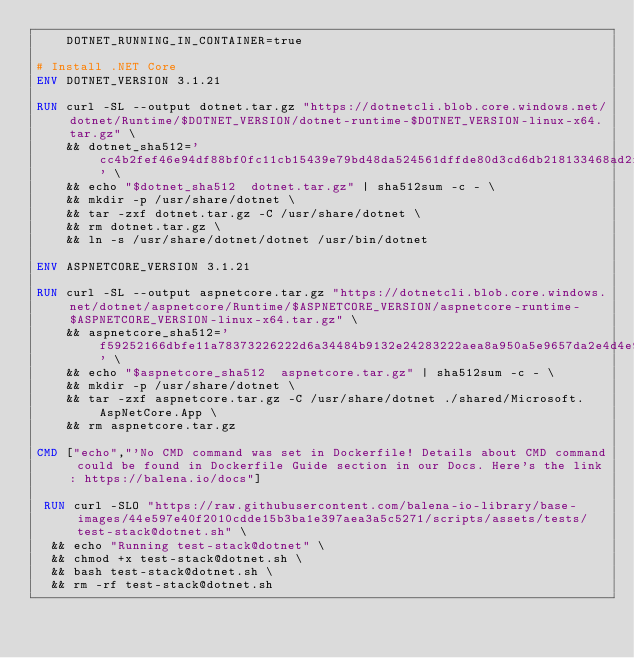<code> <loc_0><loc_0><loc_500><loc_500><_Dockerfile_>    DOTNET_RUNNING_IN_CONTAINER=true

# Install .NET Core
ENV DOTNET_VERSION 3.1.21

RUN curl -SL --output dotnet.tar.gz "https://dotnetcli.blob.core.windows.net/dotnet/Runtime/$DOTNET_VERSION/dotnet-runtime-$DOTNET_VERSION-linux-x64.tar.gz" \
    && dotnet_sha512='cc4b2fef46e94df88bf0fc11cb15439e79bd48da524561dffde80d3cd6db218133468ad2f6785803cf0c13f000d95ff71eb258cec76dd8eb809676ec1cb38fac' \
    && echo "$dotnet_sha512  dotnet.tar.gz" | sha512sum -c - \
    && mkdir -p /usr/share/dotnet \
    && tar -zxf dotnet.tar.gz -C /usr/share/dotnet \
    && rm dotnet.tar.gz \
    && ln -s /usr/share/dotnet/dotnet /usr/bin/dotnet

ENV ASPNETCORE_VERSION 3.1.21

RUN curl -SL --output aspnetcore.tar.gz "https://dotnetcli.blob.core.windows.net/dotnet/aspnetcore/Runtime/$ASPNETCORE_VERSION/aspnetcore-runtime-$ASPNETCORE_VERSION-linux-x64.tar.gz" \
    && aspnetcore_sha512='f59252166dbfe11a78373226222d6a34484b9132e24283222aea8a950a5e9657da2e4d4e9ff8cbcc2fd7c7705e13bf42a31232a6012d1e247efc718e3d8e2df1' \
    && echo "$aspnetcore_sha512  aspnetcore.tar.gz" | sha512sum -c - \
    && mkdir -p /usr/share/dotnet \
    && tar -zxf aspnetcore.tar.gz -C /usr/share/dotnet ./shared/Microsoft.AspNetCore.App \
    && rm aspnetcore.tar.gz

CMD ["echo","'No CMD command was set in Dockerfile! Details about CMD command could be found in Dockerfile Guide section in our Docs. Here's the link: https://balena.io/docs"]

 RUN curl -SLO "https://raw.githubusercontent.com/balena-io-library/base-images/44e597e40f2010cdde15b3ba1e397aea3a5c5271/scripts/assets/tests/test-stack@dotnet.sh" \
  && echo "Running test-stack@dotnet" \
  && chmod +x test-stack@dotnet.sh \
  && bash test-stack@dotnet.sh \
  && rm -rf test-stack@dotnet.sh 
</code> 